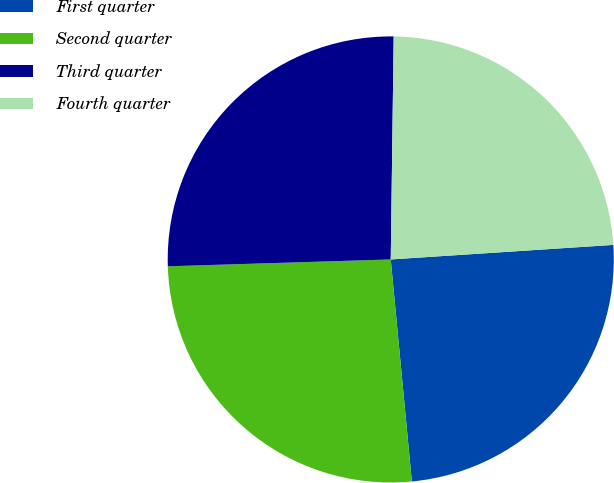Convert chart to OTSL. <chart><loc_0><loc_0><loc_500><loc_500><pie_chart><fcel>First quarter<fcel>Second quarter<fcel>Third quarter<fcel>Fourth quarter<nl><fcel>24.53%<fcel>26.02%<fcel>25.7%<fcel>23.75%<nl></chart> 